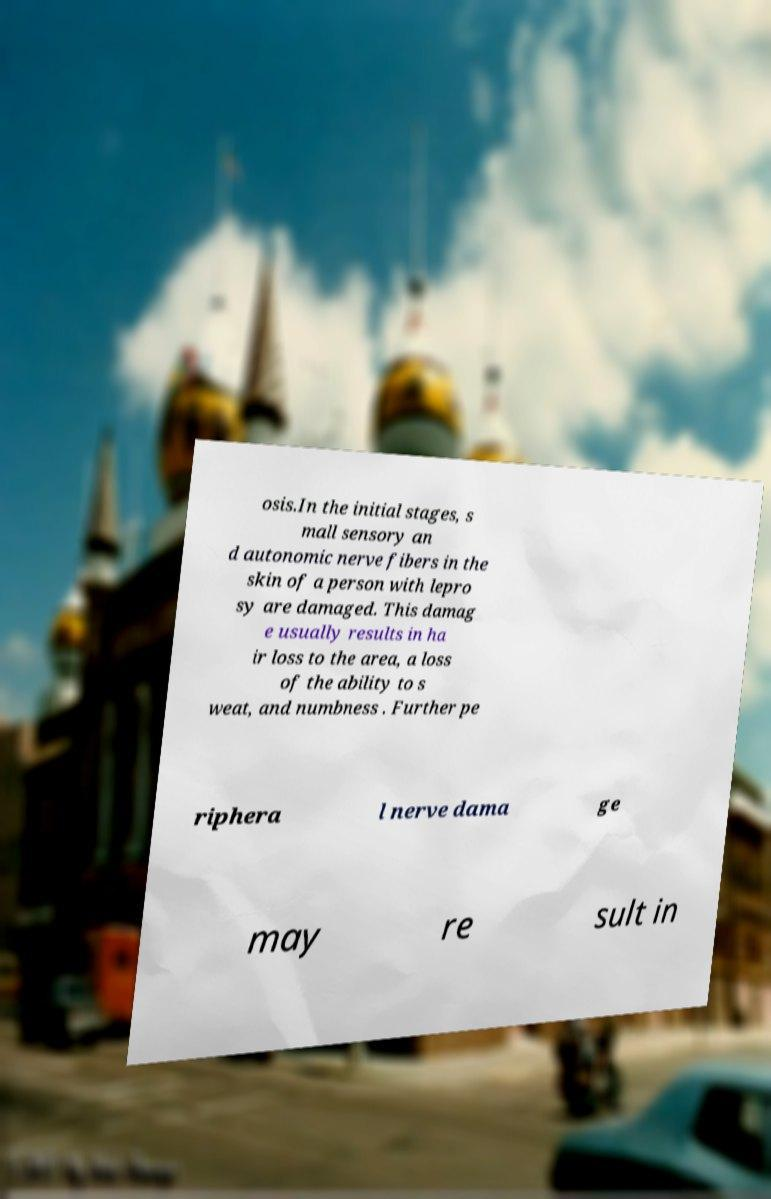Could you assist in decoding the text presented in this image and type it out clearly? osis.In the initial stages, s mall sensory an d autonomic nerve fibers in the skin of a person with lepro sy are damaged. This damag e usually results in ha ir loss to the area, a loss of the ability to s weat, and numbness . Further pe riphera l nerve dama ge may re sult in 